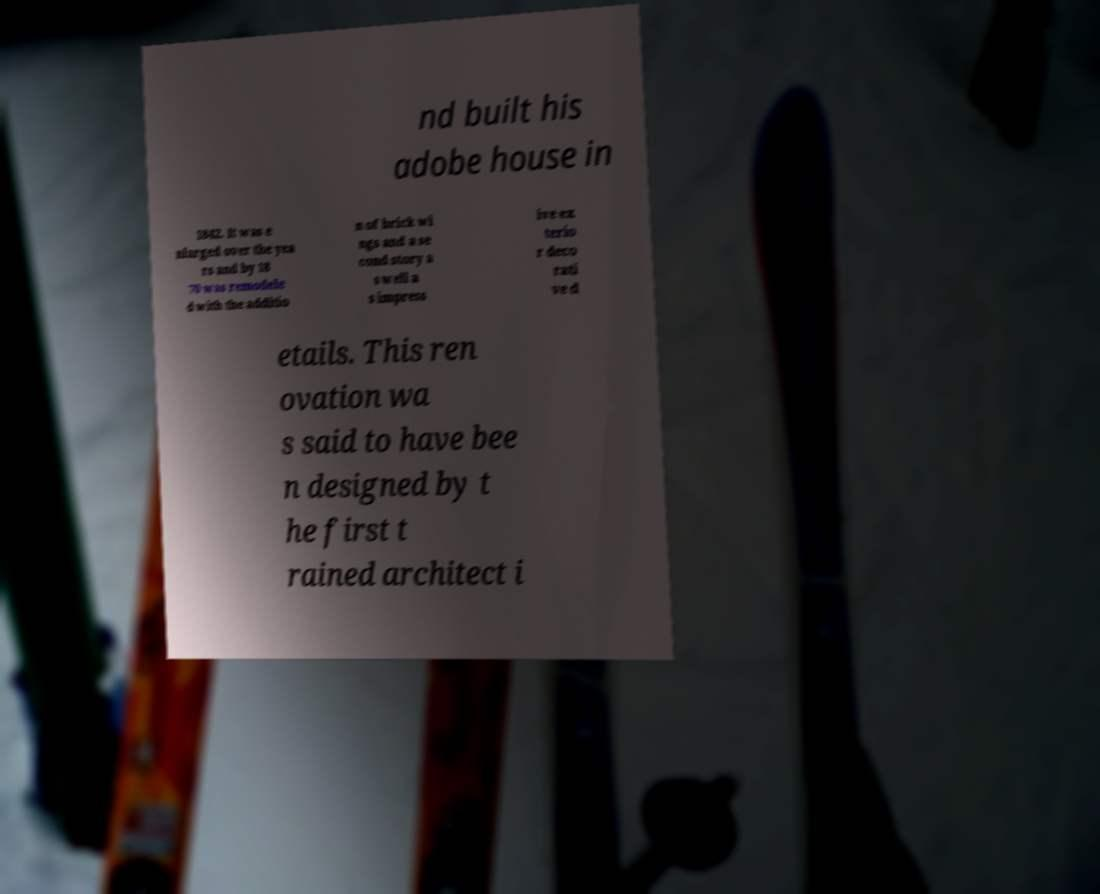Please identify and transcribe the text found in this image. nd built his adobe house in 1842. It was e nlarged over the yea rs and by 18 70 was remodele d with the additio n of brick wi ngs and a se cond story a s well a s impress ive ex terio r deco rati ve d etails. This ren ovation wa s said to have bee n designed by t he first t rained architect i 